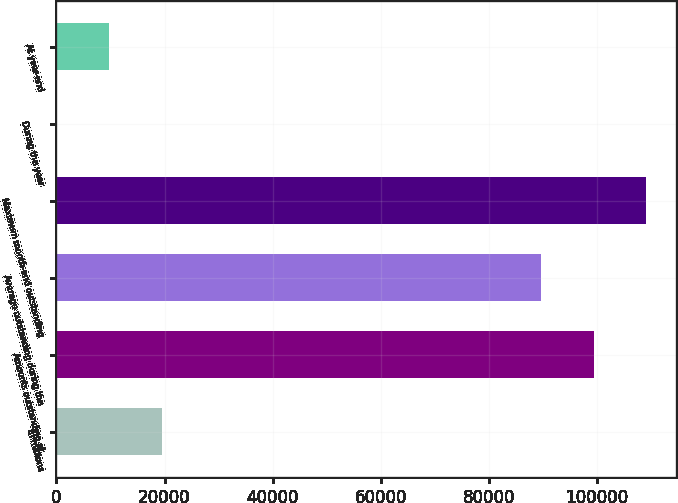<chart> <loc_0><loc_0><loc_500><loc_500><bar_chart><fcel>in millions<fcel>Amounts outstanding at<fcel>Average outstanding during the<fcel>Maximum month-end outstanding<fcel>During the year<fcel>At year-end<nl><fcel>19493.5<fcel>99408.6<fcel>89662<fcel>109155<fcel>0.37<fcel>9746.93<nl></chart> 